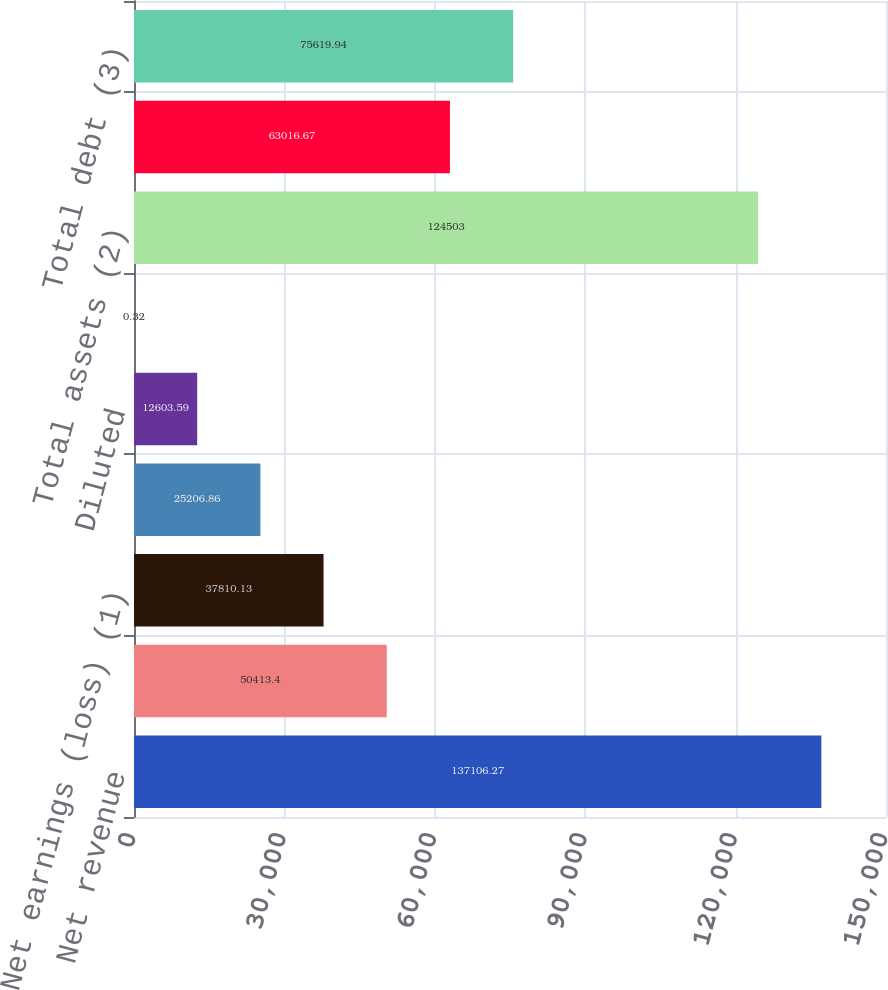Convert chart. <chart><loc_0><loc_0><loc_500><loc_500><bar_chart><fcel>Net revenue<fcel>Earnings (loss) from<fcel>Net earnings (loss) (1)<fcel>Basic<fcel>Diluted<fcel>Cash dividends declared per<fcel>Total assets (2)<fcel>Long-term debt<fcel>Total debt (3)<nl><fcel>137106<fcel>50413.4<fcel>37810.1<fcel>25206.9<fcel>12603.6<fcel>0.32<fcel>124503<fcel>63016.7<fcel>75619.9<nl></chart> 